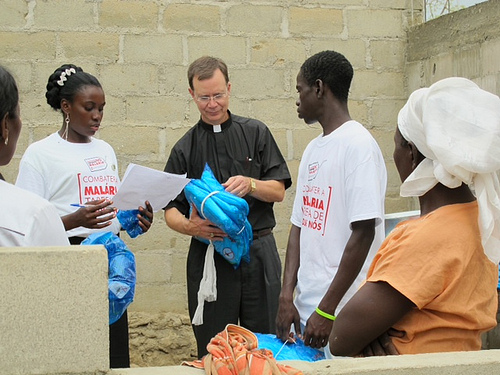<image>
Is there a watch in the woman? No. The watch is not contained within the woman. These objects have a different spatial relationship. Where is the man in relation to the man? Is it to the left of the man? Yes. From this viewpoint, the man is positioned to the left side relative to the man. 